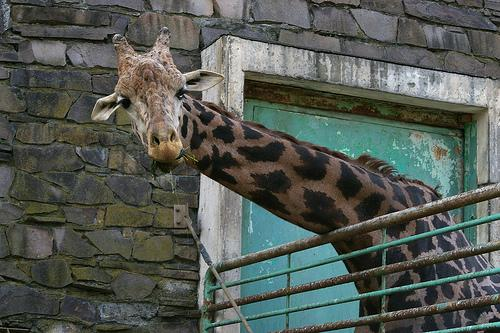Mention the primary colors and objects found in the image. There is a giraffe with black stripes and brown color, a rusted gate, a stone wall with green tiles, a green bar, and a faded door with chipped blue paint. Explain the situation involving the animal and the barrier in the image. The giraffe is behind a rusted gate with bars, some differently colored, and it seems to be looking over the railing. Describe the outdoor scene with the people in the image. People are enjoying the outdoors, with some of them close to the giraffe and the stone wall, while others are more spread out. Provide a description of the interaction between the giraffe and its surroundings. The giraffe is behind a rusted gate with bars, appearing to look over the railing, near a stone wall, while people are enjoying the outdoors around it. Provide a description of the primary animal in the image and any distinctive features it has. The main animal is a giraffe with black stripes, dark spots, and brown color on its body, as well as horns and hair on its head. Briefly describe the setting of the image including the main elements. There's a giraffe behind a rusted gate, next to a stone wall with green tiles, and people are enjoying the outdoors nearby. In a poetic manner, describe the animal and what it's doing in the image. A majestic giraffe gazes over the railing, with black stripes and dark spots adorning its towering frame, while confined behind a rusted, aged gate. State the objects and structures found in the image that are evident of wear and tear. A rusted gate, a stone wall, a faded door with chipped paint, and green railing with peeling paint can be seen in the image. Highlight the top three most significant objects in the image. The giraffe with horns and black stripes, the rusted gate it's behind, and the stone wall with green tiles and a silver pole. 